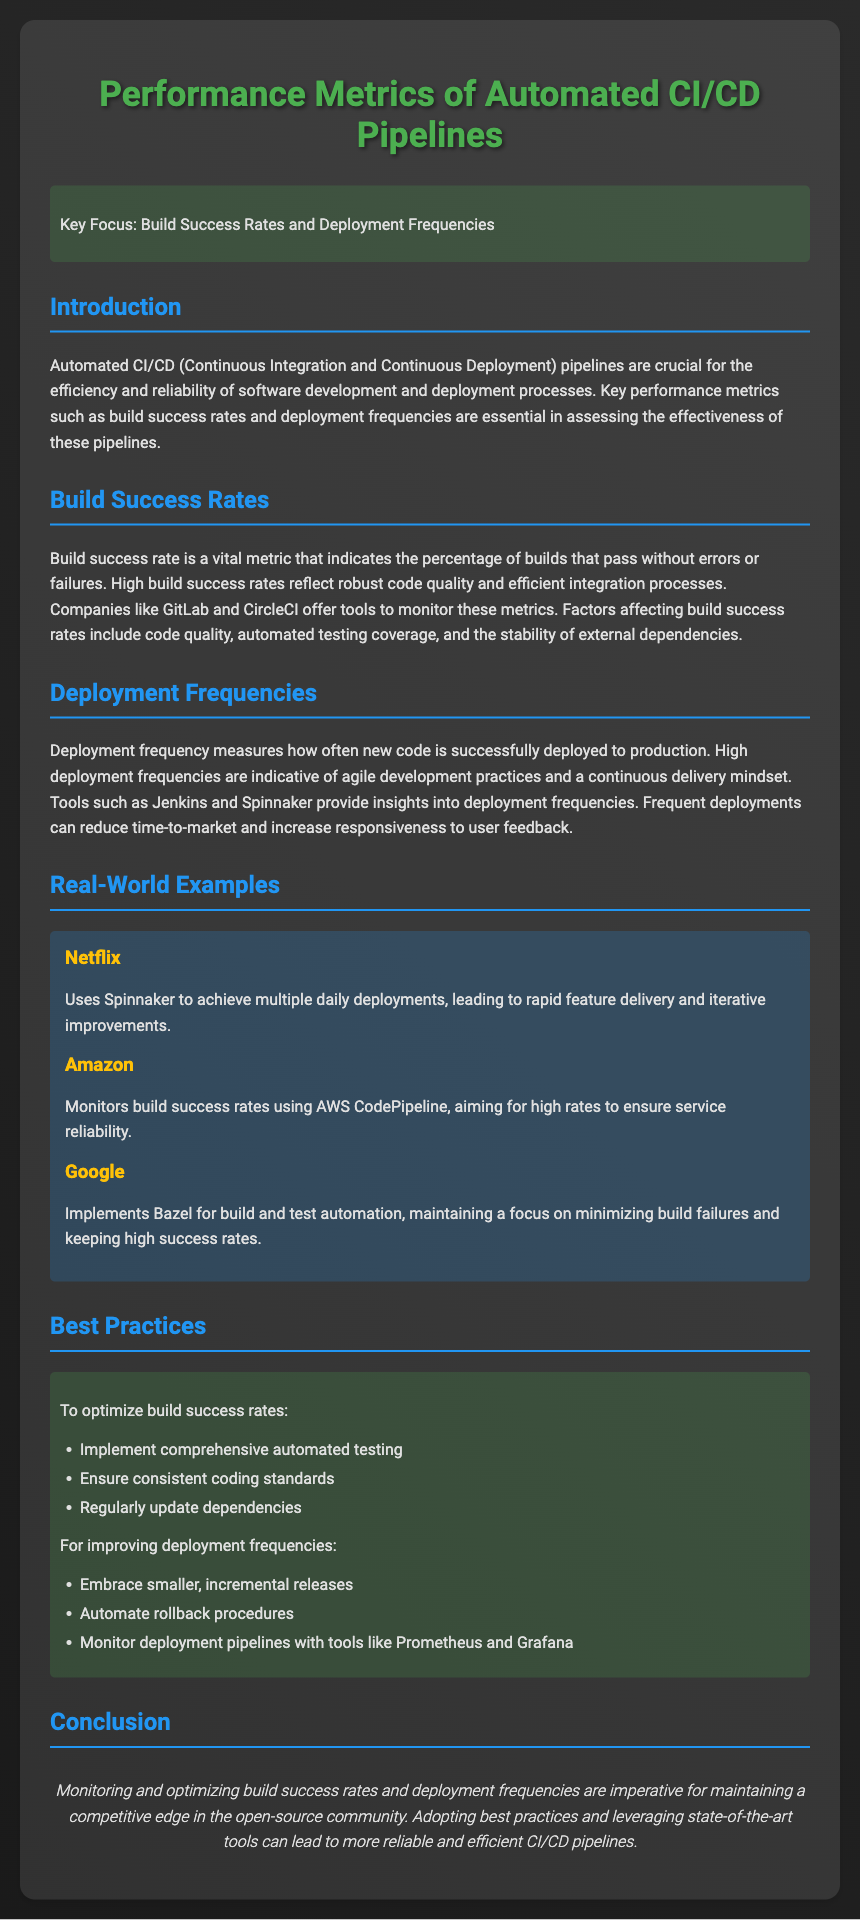What are the key focus areas? The document highlights the key focus areas related to CI/CD pipelines, specifically mentioning build success rates and deployment frequencies.
Answer: Build Success Rates and Deployment Frequencies Which companies are mentioned as examples? The document names specific companies that utilize automated CI/CD tools, including Netflix, Amazon, and Google.
Answer: Netflix, Amazon, Google What tool does Netflix use for deployments? Netflix is noted for utilizing a particular tool that facilitates their deployment strategy.
Answer: Spinnaker What metric reflects the percentage of successful builds? The document defines a metric that indicates the successful completion rate of builds, which is crucial to understanding CI/CD performance.
Answer: Build success rate What is highlighted as a best practice for improving deployment frequencies? The document recommends specific practices that help enhance the regularity of deployments in CI/CD pipelines.
Answer: Embrace smaller, incremental releases What does a high build success rate indicate? The document explains that a high percentage of successful builds signifies a particular quality in the development process.
Answer: Robust code quality What is a common tool mentioned for monitoring build success rates? The document states a popular tool that many companies employ to track their build success rates effectively.
Answer: AWS CodePipeline Which tools provide insights into deployment frequencies? The document refers to specific tools that help organizations gain visibility into how often deployments occur.
Answer: Jenkins and Spinnaker 